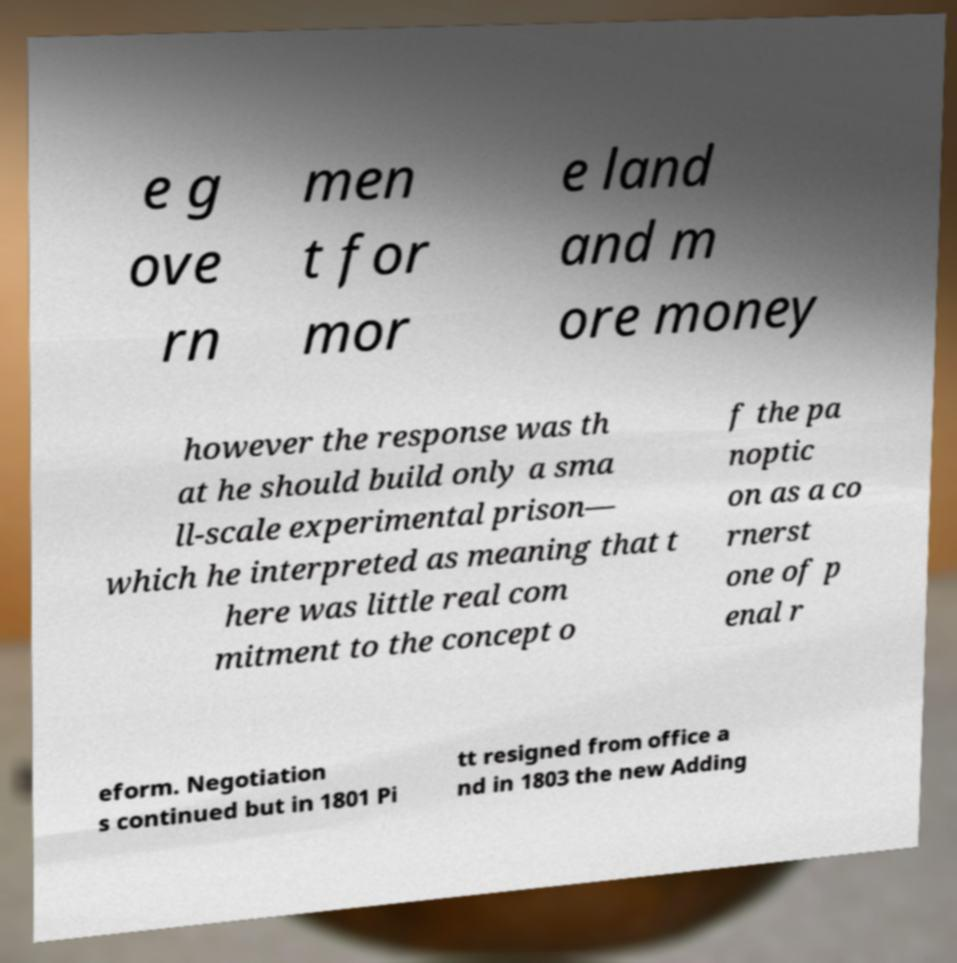For documentation purposes, I need the text within this image transcribed. Could you provide that? e g ove rn men t for mor e land and m ore money however the response was th at he should build only a sma ll-scale experimental prison— which he interpreted as meaning that t here was little real com mitment to the concept o f the pa noptic on as a co rnerst one of p enal r eform. Negotiation s continued but in 1801 Pi tt resigned from office a nd in 1803 the new Adding 